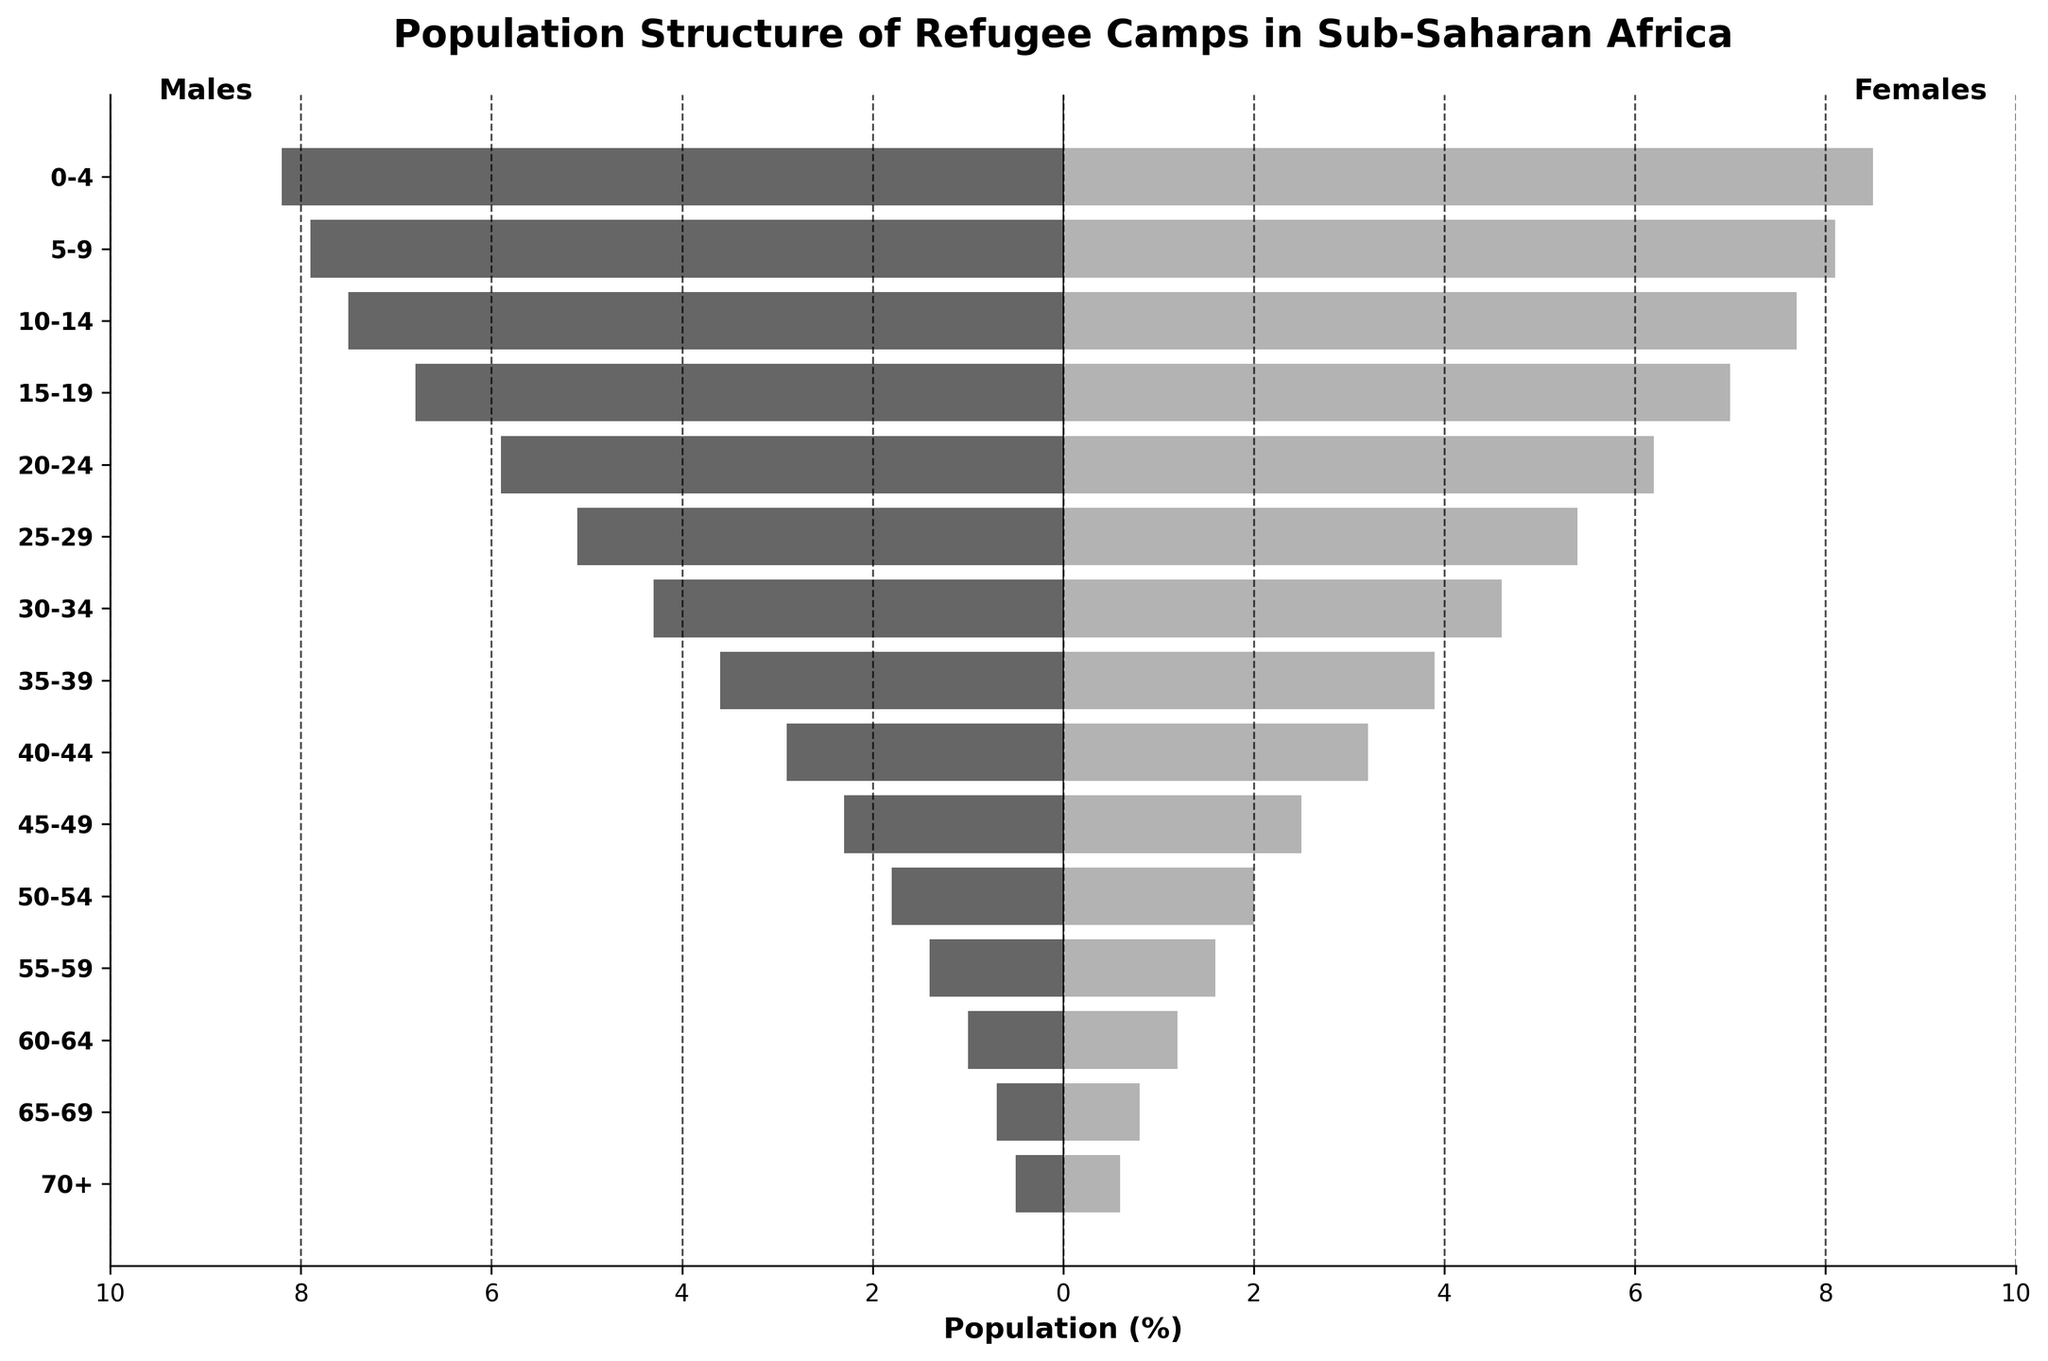How many age groups are in the population pyramid? The y-axis lists the age groups vertically. Counting them, we see a total of 15 age groups.
Answer: 15 What is the title of the figure? The title is located at the top of the figure in bold font. It reads "Population Structure of Refugee Camps in Sub-Saharan Africa."
Answer: Population Structure of Refugee Camps in Sub-Saharan Africa Which age group has the highest percentage of females? The bar that extends the farthest to the right on the graph indicates the age group with the highest percentage of females. For females, it's the 0-4 age group with 8.5%.
Answer: 0-4 What is the percentage difference between males and females in the age group 65-69? From the plot, the percentage of males is 0.7 and the percentage of females is 0.8. The difference is 0.8 - 0.7 = 0.1%.
Answer: 0.1% Which gender has a higher percentage in the 25-29 age group and by how much? In the 25-29 age group, the percentage of males is 5.1, and the percentage of females is 5.4. Females have a higher percentage by (5.4 - 5.1) = 0.3%.
Answer: Females, 0.3% Describe the trend in the male population percentages as the age increases. Observing the bars on the left representing males, they generally decrease as we move from younger to older age groups, indicating a declining trend in male percentages with increasing age.
Answer: Declining Compare the population percentages of males and females aged 10-14. Which gender has a larger percentage and what is the difference? According to the figure, males aged 10-14 have a percentage of 7.5, while females have 7.7. Females have a larger percentage by 7.7 - 7.5 = 0.2%.
Answer: Females, 0.2% What is the total percentage of males aged 0-9? By adding the percentages of males in the 0-4 and 5-9 age groups, we get 8.2 + 7.9 = 16.1%.
Answer: 16.1% At what age group does the combined percentage (males + females) first drop below 6%? Calculating the combined percentages for each age group reveals that for age group 25-29, males have 5.1% and females have 5.4%, adding up to 10.5%. The age group 30-34 has 4.3% males and 4.6% females, adding up to 8.9%. It first drops below 6% at 50-54 (1.8% + 2.0% = 3.8%).
Answer: 50-54 